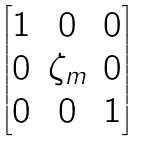<formula> <loc_0><loc_0><loc_500><loc_500>\begin{bmatrix} 1 & 0 & 0 \\ 0 & \zeta _ { m } & 0 \\ 0 & 0 & 1 \\ \end{bmatrix}</formula> 